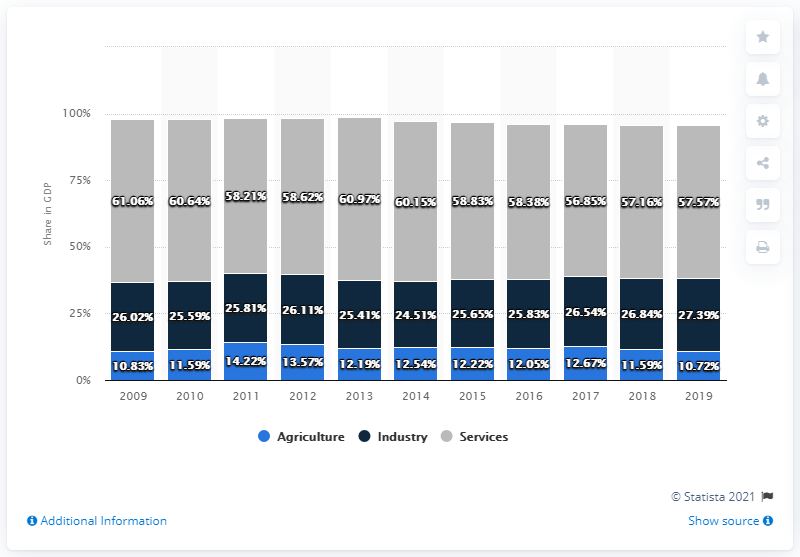Specify some key components in this picture. In 2019, agriculture accounted for 10.72% of Honduras' gross domestic product. 